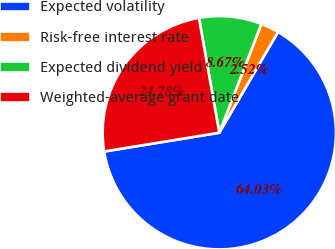Convert chart to OTSL. <chart><loc_0><loc_0><loc_500><loc_500><pie_chart><fcel>Expected volatility<fcel>Risk-free interest rate<fcel>Expected dividend yield<fcel>Weighted-average grant date<nl><fcel>64.03%<fcel>2.52%<fcel>8.67%<fcel>24.78%<nl></chart> 